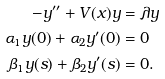<formula> <loc_0><loc_0><loc_500><loc_500>- y ^ { \prime \prime } + V ( x ) y & = \lambda y \\ \alpha _ { 1 } y ( 0 ) + \alpha _ { 2 } y ^ { \prime } ( 0 ) & = 0 \\ \beta _ { 1 } y ( s ) + \beta _ { 2 } y ^ { \prime } ( s ) & = 0 .</formula> 